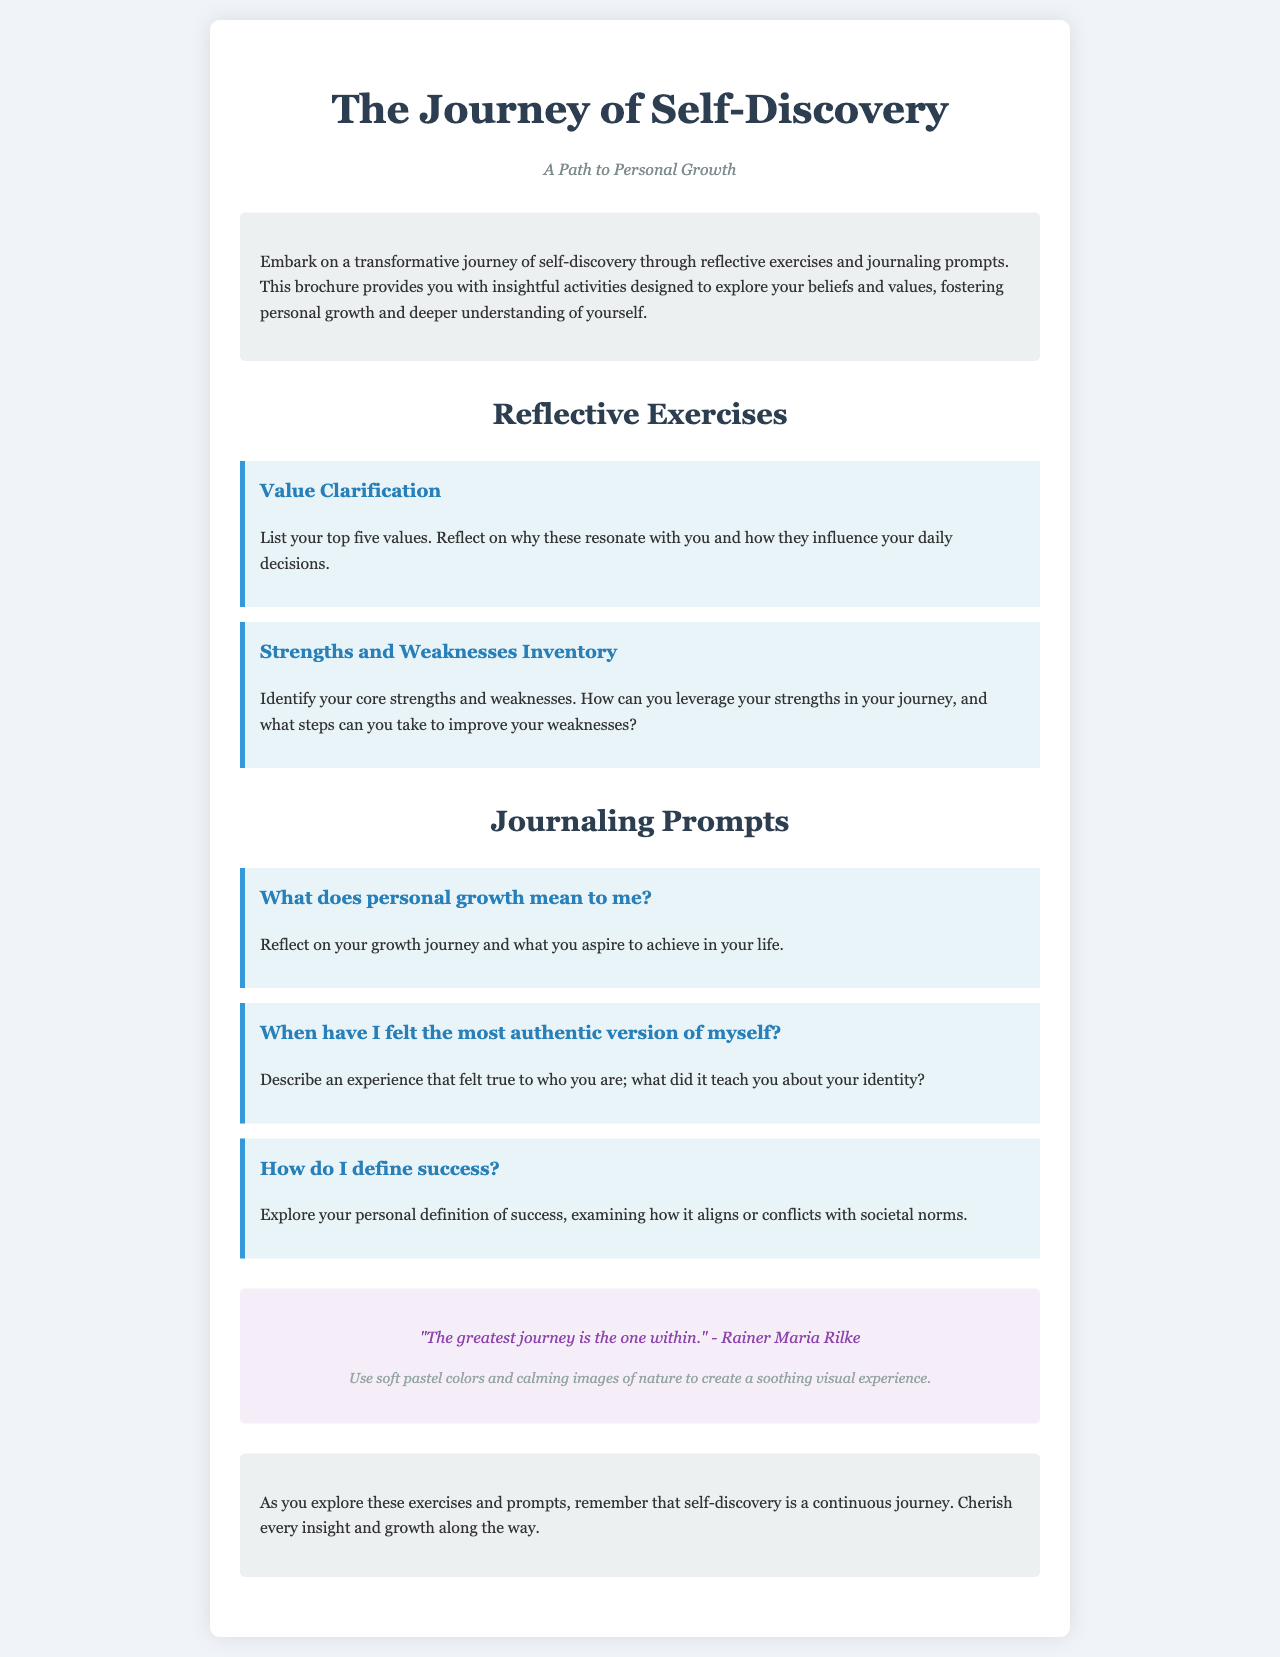what is the title of the brochure? The title is prominently displayed at the top of the document, indicating the focus of the content.
Answer: The Journey of Self-Discovery what is the subtitle of the brochure? The subtitle is located under the title and highlights the theme of the brochure.
Answer: A Path to Personal Growth how many reflective exercises are included in the document? The document lists the exercises under a dedicated section; the number of exercises can be counted directly.
Answer: 2 what is one of the journaling prompts provided? The prompts are listed with specific headings, so one can be directly referenced from the document.
Answer: What does personal growth mean to me? who is quoted in the inspiration section? The quote is provided in the inspiration section, where the author is mentioned along with the quote text.
Answer: Rainer Maria Rilke what color scheme is suggested for graphics in the brochure? The graphic suggestion is explicitly mentioned in a designated area of the document.
Answer: Soft pastel colors what is encouraged regarding the self-discovery journey? This message is conveyed in the closing section, emphasizing the attitude one should have toward their journey.
Answer: Cherish every insight and growth along the way what should be reflected in the "Strengths and Weaknesses Inventory" exercise? The details of the exercise guide readers on what to analyze regarding their traits.
Answer: Core strengths and weaknesses 